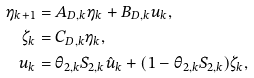<formula> <loc_0><loc_0><loc_500><loc_500>\eta _ { k + 1 } & = A _ { D , k } \eta _ { k } + B _ { D , k } u _ { k } , \\ \zeta _ { k } & = C _ { D , k } \eta _ { k } , \\ u _ { k } & = \theta _ { 2 , k } S _ { 2 , k } \hat { u } _ { k } + ( 1 - \theta _ { 2 , k } S _ { 2 , k } ) \zeta _ { k } ,</formula> 